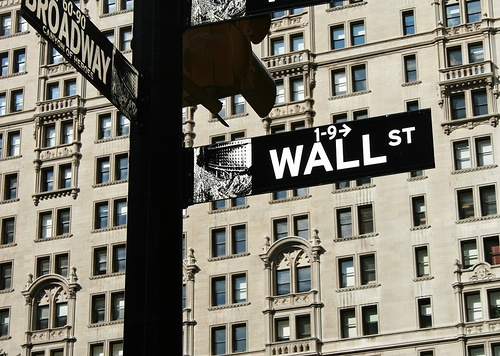Describe the objects in this image and their specific colors. I can see a traffic light in black, beige, gray, and lightgray tones in this image. 